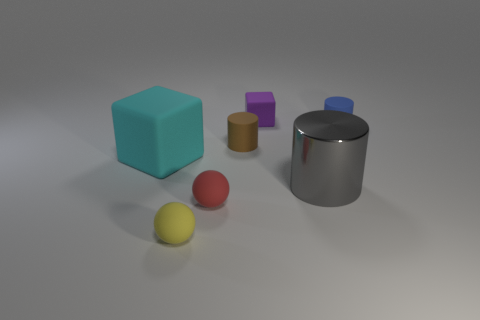Do the block in front of the small rubber cube and the blue cylinder have the same material?
Make the answer very short. Yes. What is the object that is left of the tiny purple object and on the right side of the red rubber thing made of?
Your answer should be very brief. Rubber. The cylinder in front of the block in front of the purple matte thing is what color?
Your response must be concise. Gray. What material is the purple thing that is the same shape as the cyan object?
Your response must be concise. Rubber. What color is the tiny cylinder that is left of the tiny cylinder behind the small rubber cylinder that is in front of the blue cylinder?
Ensure brevity in your answer.  Brown. What number of things are large rubber cubes or cyan metal balls?
Provide a short and direct response. 1. How many other small matte objects have the same shape as the brown thing?
Keep it short and to the point. 1. Is the material of the big cyan block the same as the tiny red ball in front of the gray shiny cylinder?
Offer a very short reply. Yes. The cyan object that is the same material as the yellow thing is what size?
Your answer should be compact. Large. There is a rubber cube to the right of the red rubber thing; how big is it?
Offer a very short reply. Small. 